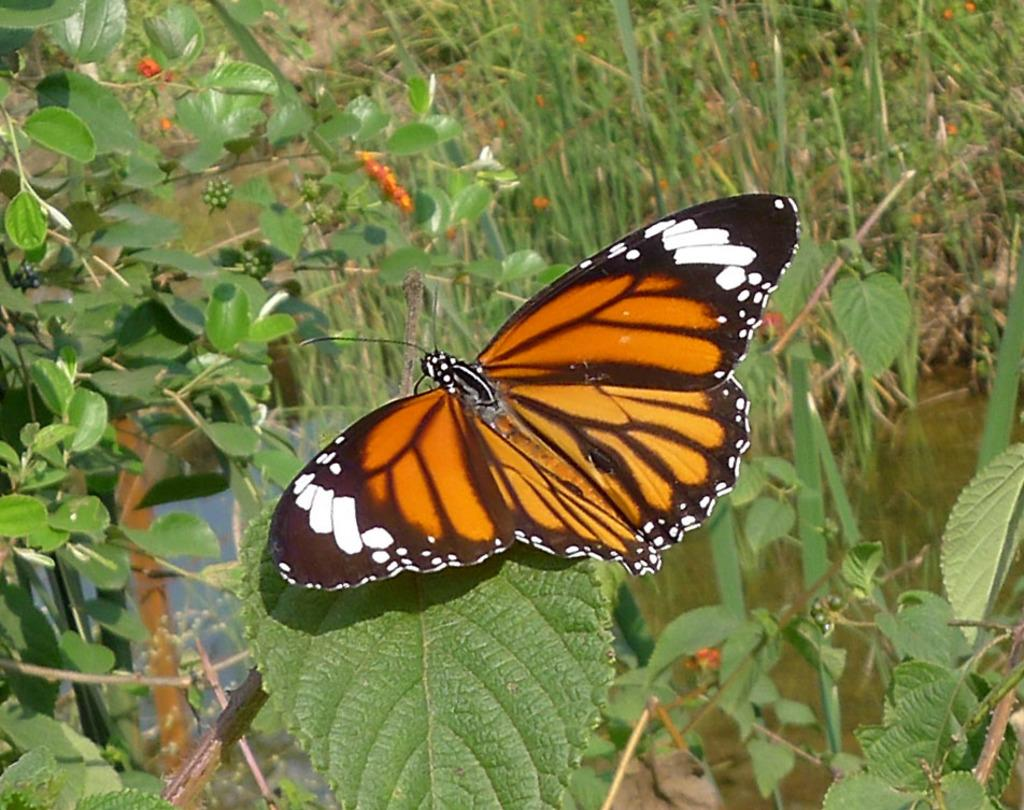What is the main subject in the foreground of the image? There is a butterfly on a leaf in the foreground of the image. What can be seen in the background of the image? There are plants and grass in the background of the image, as well as water. Can you describe the natural environment depicted in the image? The image features a butterfly on a leaf, surrounded by plants, grass, and water in the background. Reasoning: Let's think step by step by step in order to produce the conversation. We start by identifying the main subject in the foreground, which is the butterfly on a leaf. Then, we expand the conversation to include the background elements, such as plants, grass, and water. We ensure that each question is focused on a specific detail about the image that is known from the provided facts. Absurd Question/Answer: What type of arch can be seen in the image? There is no arch present in the image. How many sticks are visible in the image? There are no sticks visible in the image. How many sticks are supporting the arch in the image? There is no arch or sticks present in the image. 